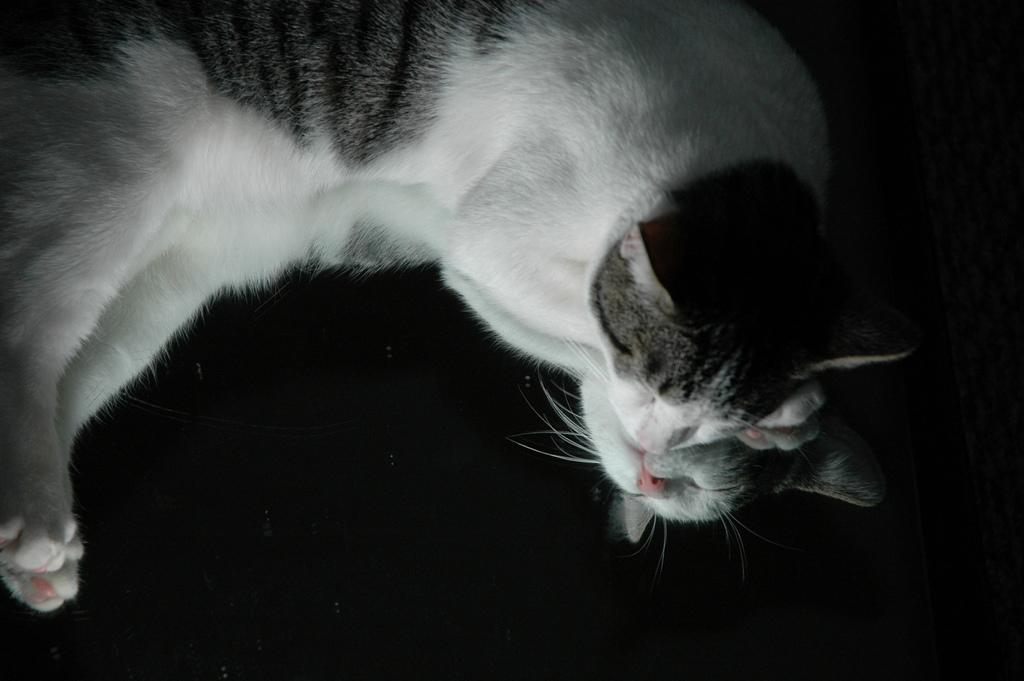What type of animal is in the image? There is a cat in the image. Where is the cat located in the image? The cat is lying on the floor. What is the cat doing in the image? The cat is sleeping. What type of drink is the cat holding in the image? There is no drink present in the image, and the cat is not holding anything. 